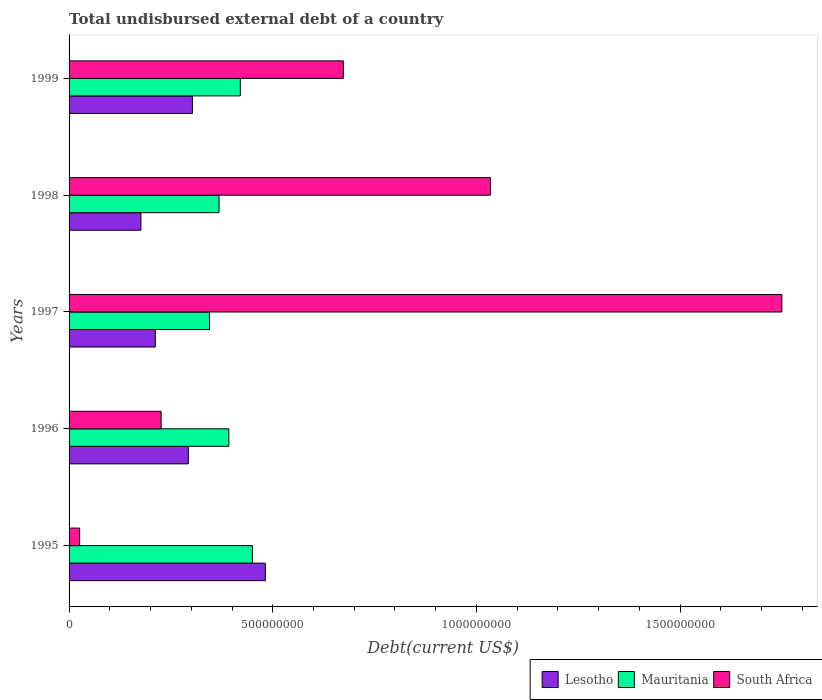How many groups of bars are there?
Your answer should be compact. 5. How many bars are there on the 3rd tick from the bottom?
Your answer should be compact. 3. In how many cases, is the number of bars for a given year not equal to the number of legend labels?
Keep it short and to the point. 0. What is the total undisbursed external debt in Lesotho in 1996?
Keep it short and to the point. 2.93e+08. Across all years, what is the maximum total undisbursed external debt in South Africa?
Give a very brief answer. 1.75e+09. Across all years, what is the minimum total undisbursed external debt in Mauritania?
Make the answer very short. 3.45e+08. What is the total total undisbursed external debt in Lesotho in the graph?
Offer a very short reply. 1.47e+09. What is the difference between the total undisbursed external debt in Lesotho in 1995 and that in 1997?
Your response must be concise. 2.70e+08. What is the difference between the total undisbursed external debt in Mauritania in 1996 and the total undisbursed external debt in Lesotho in 1997?
Keep it short and to the point. 1.81e+08. What is the average total undisbursed external debt in Mauritania per year?
Offer a very short reply. 3.95e+08. In the year 1995, what is the difference between the total undisbursed external debt in South Africa and total undisbursed external debt in Lesotho?
Provide a succinct answer. -4.56e+08. In how many years, is the total undisbursed external debt in Lesotho greater than 800000000 US$?
Provide a short and direct response. 0. What is the ratio of the total undisbursed external debt in South Africa in 1996 to that in 1997?
Your response must be concise. 0.13. What is the difference between the highest and the second highest total undisbursed external debt in Lesotho?
Offer a very short reply. 1.79e+08. What is the difference between the highest and the lowest total undisbursed external debt in Mauritania?
Your answer should be compact. 1.05e+08. In how many years, is the total undisbursed external debt in South Africa greater than the average total undisbursed external debt in South Africa taken over all years?
Your answer should be compact. 2. What does the 3rd bar from the top in 1999 represents?
Ensure brevity in your answer.  Lesotho. What does the 2nd bar from the bottom in 1995 represents?
Your answer should be compact. Mauritania. Is it the case that in every year, the sum of the total undisbursed external debt in Mauritania and total undisbursed external debt in Lesotho is greater than the total undisbursed external debt in South Africa?
Give a very brief answer. No. How many bars are there?
Keep it short and to the point. 15. Are the values on the major ticks of X-axis written in scientific E-notation?
Give a very brief answer. No. Where does the legend appear in the graph?
Your answer should be compact. Bottom right. How many legend labels are there?
Offer a very short reply. 3. How are the legend labels stacked?
Keep it short and to the point. Horizontal. What is the title of the graph?
Provide a short and direct response. Total undisbursed external debt of a country. What is the label or title of the X-axis?
Make the answer very short. Debt(current US$). What is the Debt(current US$) in Lesotho in 1995?
Ensure brevity in your answer.  4.82e+08. What is the Debt(current US$) in Mauritania in 1995?
Ensure brevity in your answer.  4.50e+08. What is the Debt(current US$) of South Africa in 1995?
Give a very brief answer. 2.59e+07. What is the Debt(current US$) in Lesotho in 1996?
Ensure brevity in your answer.  2.93e+08. What is the Debt(current US$) of Mauritania in 1996?
Your response must be concise. 3.92e+08. What is the Debt(current US$) of South Africa in 1996?
Provide a short and direct response. 2.26e+08. What is the Debt(current US$) of Lesotho in 1997?
Provide a succinct answer. 2.12e+08. What is the Debt(current US$) of Mauritania in 1997?
Your answer should be compact. 3.45e+08. What is the Debt(current US$) of South Africa in 1997?
Keep it short and to the point. 1.75e+09. What is the Debt(current US$) in Lesotho in 1998?
Offer a terse response. 1.76e+08. What is the Debt(current US$) in Mauritania in 1998?
Give a very brief answer. 3.68e+08. What is the Debt(current US$) of South Africa in 1998?
Ensure brevity in your answer.  1.03e+09. What is the Debt(current US$) in Lesotho in 1999?
Give a very brief answer. 3.03e+08. What is the Debt(current US$) in Mauritania in 1999?
Offer a terse response. 4.20e+08. What is the Debt(current US$) in South Africa in 1999?
Make the answer very short. 6.73e+08. Across all years, what is the maximum Debt(current US$) of Lesotho?
Make the answer very short. 4.82e+08. Across all years, what is the maximum Debt(current US$) of Mauritania?
Provide a succinct answer. 4.50e+08. Across all years, what is the maximum Debt(current US$) of South Africa?
Your answer should be compact. 1.75e+09. Across all years, what is the minimum Debt(current US$) of Lesotho?
Offer a very short reply. 1.76e+08. Across all years, what is the minimum Debt(current US$) in Mauritania?
Provide a short and direct response. 3.45e+08. Across all years, what is the minimum Debt(current US$) of South Africa?
Your answer should be very brief. 2.59e+07. What is the total Debt(current US$) of Lesotho in the graph?
Your answer should be compact. 1.47e+09. What is the total Debt(current US$) of Mauritania in the graph?
Your answer should be very brief. 1.98e+09. What is the total Debt(current US$) in South Africa in the graph?
Give a very brief answer. 3.71e+09. What is the difference between the Debt(current US$) of Lesotho in 1995 and that in 1996?
Offer a terse response. 1.89e+08. What is the difference between the Debt(current US$) in Mauritania in 1995 and that in 1996?
Provide a succinct answer. 5.79e+07. What is the difference between the Debt(current US$) of South Africa in 1995 and that in 1996?
Your response must be concise. -2.00e+08. What is the difference between the Debt(current US$) in Lesotho in 1995 and that in 1997?
Make the answer very short. 2.70e+08. What is the difference between the Debt(current US$) of Mauritania in 1995 and that in 1997?
Keep it short and to the point. 1.05e+08. What is the difference between the Debt(current US$) of South Africa in 1995 and that in 1997?
Your answer should be compact. -1.72e+09. What is the difference between the Debt(current US$) in Lesotho in 1995 and that in 1998?
Your answer should be compact. 3.06e+08. What is the difference between the Debt(current US$) in Mauritania in 1995 and that in 1998?
Offer a very short reply. 8.19e+07. What is the difference between the Debt(current US$) in South Africa in 1995 and that in 1998?
Keep it short and to the point. -1.01e+09. What is the difference between the Debt(current US$) in Lesotho in 1995 and that in 1999?
Ensure brevity in your answer.  1.79e+08. What is the difference between the Debt(current US$) of Mauritania in 1995 and that in 1999?
Provide a succinct answer. 2.96e+07. What is the difference between the Debt(current US$) of South Africa in 1995 and that in 1999?
Offer a terse response. -6.47e+08. What is the difference between the Debt(current US$) in Lesotho in 1996 and that in 1997?
Offer a very short reply. 8.11e+07. What is the difference between the Debt(current US$) in Mauritania in 1996 and that in 1997?
Ensure brevity in your answer.  4.75e+07. What is the difference between the Debt(current US$) of South Africa in 1996 and that in 1997?
Offer a very short reply. -1.52e+09. What is the difference between the Debt(current US$) of Lesotho in 1996 and that in 1998?
Ensure brevity in your answer.  1.16e+08. What is the difference between the Debt(current US$) in Mauritania in 1996 and that in 1998?
Ensure brevity in your answer.  2.40e+07. What is the difference between the Debt(current US$) of South Africa in 1996 and that in 1998?
Offer a very short reply. -8.08e+08. What is the difference between the Debt(current US$) in Lesotho in 1996 and that in 1999?
Offer a terse response. -1.01e+07. What is the difference between the Debt(current US$) in Mauritania in 1996 and that in 1999?
Your answer should be very brief. -2.82e+07. What is the difference between the Debt(current US$) in South Africa in 1996 and that in 1999?
Provide a succinct answer. -4.47e+08. What is the difference between the Debt(current US$) of Lesotho in 1997 and that in 1998?
Provide a short and direct response. 3.53e+07. What is the difference between the Debt(current US$) in Mauritania in 1997 and that in 1998?
Give a very brief answer. -2.35e+07. What is the difference between the Debt(current US$) in South Africa in 1997 and that in 1998?
Offer a terse response. 7.16e+08. What is the difference between the Debt(current US$) in Lesotho in 1997 and that in 1999?
Offer a terse response. -9.12e+07. What is the difference between the Debt(current US$) in Mauritania in 1997 and that in 1999?
Ensure brevity in your answer.  -7.57e+07. What is the difference between the Debt(current US$) of South Africa in 1997 and that in 1999?
Make the answer very short. 1.08e+09. What is the difference between the Debt(current US$) of Lesotho in 1998 and that in 1999?
Make the answer very short. -1.26e+08. What is the difference between the Debt(current US$) of Mauritania in 1998 and that in 1999?
Provide a short and direct response. -5.22e+07. What is the difference between the Debt(current US$) in South Africa in 1998 and that in 1999?
Your answer should be very brief. 3.61e+08. What is the difference between the Debt(current US$) of Lesotho in 1995 and the Debt(current US$) of Mauritania in 1996?
Make the answer very short. 8.97e+07. What is the difference between the Debt(current US$) of Lesotho in 1995 and the Debt(current US$) of South Africa in 1996?
Give a very brief answer. 2.56e+08. What is the difference between the Debt(current US$) of Mauritania in 1995 and the Debt(current US$) of South Africa in 1996?
Ensure brevity in your answer.  2.24e+08. What is the difference between the Debt(current US$) of Lesotho in 1995 and the Debt(current US$) of Mauritania in 1997?
Make the answer very short. 1.37e+08. What is the difference between the Debt(current US$) of Lesotho in 1995 and the Debt(current US$) of South Africa in 1997?
Your answer should be compact. -1.27e+09. What is the difference between the Debt(current US$) in Mauritania in 1995 and the Debt(current US$) in South Africa in 1997?
Your answer should be compact. -1.30e+09. What is the difference between the Debt(current US$) of Lesotho in 1995 and the Debt(current US$) of Mauritania in 1998?
Give a very brief answer. 1.14e+08. What is the difference between the Debt(current US$) of Lesotho in 1995 and the Debt(current US$) of South Africa in 1998?
Provide a succinct answer. -5.52e+08. What is the difference between the Debt(current US$) in Mauritania in 1995 and the Debt(current US$) in South Africa in 1998?
Offer a terse response. -5.84e+08. What is the difference between the Debt(current US$) in Lesotho in 1995 and the Debt(current US$) in Mauritania in 1999?
Your answer should be very brief. 6.15e+07. What is the difference between the Debt(current US$) of Lesotho in 1995 and the Debt(current US$) of South Africa in 1999?
Provide a succinct answer. -1.91e+08. What is the difference between the Debt(current US$) of Mauritania in 1995 and the Debt(current US$) of South Africa in 1999?
Your answer should be very brief. -2.23e+08. What is the difference between the Debt(current US$) in Lesotho in 1996 and the Debt(current US$) in Mauritania in 1997?
Ensure brevity in your answer.  -5.20e+07. What is the difference between the Debt(current US$) of Lesotho in 1996 and the Debt(current US$) of South Africa in 1997?
Your answer should be compact. -1.46e+09. What is the difference between the Debt(current US$) of Mauritania in 1996 and the Debt(current US$) of South Africa in 1997?
Offer a very short reply. -1.36e+09. What is the difference between the Debt(current US$) of Lesotho in 1996 and the Debt(current US$) of Mauritania in 1998?
Provide a short and direct response. -7.54e+07. What is the difference between the Debt(current US$) of Lesotho in 1996 and the Debt(current US$) of South Africa in 1998?
Ensure brevity in your answer.  -7.42e+08. What is the difference between the Debt(current US$) of Mauritania in 1996 and the Debt(current US$) of South Africa in 1998?
Provide a short and direct response. -6.42e+08. What is the difference between the Debt(current US$) in Lesotho in 1996 and the Debt(current US$) in Mauritania in 1999?
Your response must be concise. -1.28e+08. What is the difference between the Debt(current US$) in Lesotho in 1996 and the Debt(current US$) in South Africa in 1999?
Your answer should be very brief. -3.81e+08. What is the difference between the Debt(current US$) of Mauritania in 1996 and the Debt(current US$) of South Africa in 1999?
Offer a very short reply. -2.81e+08. What is the difference between the Debt(current US$) of Lesotho in 1997 and the Debt(current US$) of Mauritania in 1998?
Ensure brevity in your answer.  -1.57e+08. What is the difference between the Debt(current US$) of Lesotho in 1997 and the Debt(current US$) of South Africa in 1998?
Ensure brevity in your answer.  -8.23e+08. What is the difference between the Debt(current US$) in Mauritania in 1997 and the Debt(current US$) in South Africa in 1998?
Your answer should be very brief. -6.90e+08. What is the difference between the Debt(current US$) in Lesotho in 1997 and the Debt(current US$) in Mauritania in 1999?
Keep it short and to the point. -2.09e+08. What is the difference between the Debt(current US$) in Lesotho in 1997 and the Debt(current US$) in South Africa in 1999?
Your answer should be very brief. -4.62e+08. What is the difference between the Debt(current US$) in Mauritania in 1997 and the Debt(current US$) in South Africa in 1999?
Your answer should be compact. -3.29e+08. What is the difference between the Debt(current US$) of Lesotho in 1998 and the Debt(current US$) of Mauritania in 1999?
Provide a succinct answer. -2.44e+08. What is the difference between the Debt(current US$) in Lesotho in 1998 and the Debt(current US$) in South Africa in 1999?
Ensure brevity in your answer.  -4.97e+08. What is the difference between the Debt(current US$) of Mauritania in 1998 and the Debt(current US$) of South Africa in 1999?
Provide a succinct answer. -3.05e+08. What is the average Debt(current US$) of Lesotho per year?
Offer a terse response. 2.93e+08. What is the average Debt(current US$) of Mauritania per year?
Offer a very short reply. 3.95e+08. What is the average Debt(current US$) in South Africa per year?
Ensure brevity in your answer.  7.42e+08. In the year 1995, what is the difference between the Debt(current US$) of Lesotho and Debt(current US$) of Mauritania?
Your answer should be compact. 3.19e+07. In the year 1995, what is the difference between the Debt(current US$) in Lesotho and Debt(current US$) in South Africa?
Your response must be concise. 4.56e+08. In the year 1995, what is the difference between the Debt(current US$) in Mauritania and Debt(current US$) in South Africa?
Provide a short and direct response. 4.24e+08. In the year 1996, what is the difference between the Debt(current US$) in Lesotho and Debt(current US$) in Mauritania?
Keep it short and to the point. -9.94e+07. In the year 1996, what is the difference between the Debt(current US$) in Lesotho and Debt(current US$) in South Africa?
Offer a terse response. 6.68e+07. In the year 1996, what is the difference between the Debt(current US$) of Mauritania and Debt(current US$) of South Africa?
Keep it short and to the point. 1.66e+08. In the year 1997, what is the difference between the Debt(current US$) of Lesotho and Debt(current US$) of Mauritania?
Your answer should be compact. -1.33e+08. In the year 1997, what is the difference between the Debt(current US$) in Lesotho and Debt(current US$) in South Africa?
Give a very brief answer. -1.54e+09. In the year 1997, what is the difference between the Debt(current US$) in Mauritania and Debt(current US$) in South Africa?
Your response must be concise. -1.41e+09. In the year 1998, what is the difference between the Debt(current US$) in Lesotho and Debt(current US$) in Mauritania?
Provide a succinct answer. -1.92e+08. In the year 1998, what is the difference between the Debt(current US$) of Lesotho and Debt(current US$) of South Africa?
Offer a terse response. -8.58e+08. In the year 1998, what is the difference between the Debt(current US$) in Mauritania and Debt(current US$) in South Africa?
Provide a succinct answer. -6.66e+08. In the year 1999, what is the difference between the Debt(current US$) in Lesotho and Debt(current US$) in Mauritania?
Offer a terse response. -1.18e+08. In the year 1999, what is the difference between the Debt(current US$) in Lesotho and Debt(current US$) in South Africa?
Provide a short and direct response. -3.70e+08. In the year 1999, what is the difference between the Debt(current US$) of Mauritania and Debt(current US$) of South Africa?
Offer a very short reply. -2.53e+08. What is the ratio of the Debt(current US$) in Lesotho in 1995 to that in 1996?
Provide a succinct answer. 1.65. What is the ratio of the Debt(current US$) in Mauritania in 1995 to that in 1996?
Make the answer very short. 1.15. What is the ratio of the Debt(current US$) of South Africa in 1995 to that in 1996?
Offer a terse response. 0.11. What is the ratio of the Debt(current US$) in Lesotho in 1995 to that in 1997?
Your response must be concise. 2.28. What is the ratio of the Debt(current US$) in Mauritania in 1995 to that in 1997?
Provide a succinct answer. 1.31. What is the ratio of the Debt(current US$) of South Africa in 1995 to that in 1997?
Give a very brief answer. 0.01. What is the ratio of the Debt(current US$) of Lesotho in 1995 to that in 1998?
Offer a very short reply. 2.73. What is the ratio of the Debt(current US$) of Mauritania in 1995 to that in 1998?
Provide a succinct answer. 1.22. What is the ratio of the Debt(current US$) in South Africa in 1995 to that in 1998?
Offer a very short reply. 0.03. What is the ratio of the Debt(current US$) of Lesotho in 1995 to that in 1999?
Keep it short and to the point. 1.59. What is the ratio of the Debt(current US$) in Mauritania in 1995 to that in 1999?
Your answer should be compact. 1.07. What is the ratio of the Debt(current US$) in South Africa in 1995 to that in 1999?
Provide a short and direct response. 0.04. What is the ratio of the Debt(current US$) in Lesotho in 1996 to that in 1997?
Provide a short and direct response. 1.38. What is the ratio of the Debt(current US$) of Mauritania in 1996 to that in 1997?
Your response must be concise. 1.14. What is the ratio of the Debt(current US$) of South Africa in 1996 to that in 1997?
Provide a short and direct response. 0.13. What is the ratio of the Debt(current US$) of Lesotho in 1996 to that in 1998?
Your answer should be compact. 1.66. What is the ratio of the Debt(current US$) of Mauritania in 1996 to that in 1998?
Give a very brief answer. 1.07. What is the ratio of the Debt(current US$) in South Africa in 1996 to that in 1998?
Your answer should be compact. 0.22. What is the ratio of the Debt(current US$) in Lesotho in 1996 to that in 1999?
Ensure brevity in your answer.  0.97. What is the ratio of the Debt(current US$) in Mauritania in 1996 to that in 1999?
Provide a short and direct response. 0.93. What is the ratio of the Debt(current US$) of South Africa in 1996 to that in 1999?
Offer a terse response. 0.34. What is the ratio of the Debt(current US$) of Lesotho in 1997 to that in 1998?
Ensure brevity in your answer.  1.2. What is the ratio of the Debt(current US$) of Mauritania in 1997 to that in 1998?
Make the answer very short. 0.94. What is the ratio of the Debt(current US$) of South Africa in 1997 to that in 1998?
Give a very brief answer. 1.69. What is the ratio of the Debt(current US$) in Lesotho in 1997 to that in 1999?
Your answer should be very brief. 0.7. What is the ratio of the Debt(current US$) of Mauritania in 1997 to that in 1999?
Ensure brevity in your answer.  0.82. What is the ratio of the Debt(current US$) in South Africa in 1997 to that in 1999?
Offer a terse response. 2.6. What is the ratio of the Debt(current US$) of Lesotho in 1998 to that in 1999?
Your answer should be compact. 0.58. What is the ratio of the Debt(current US$) of Mauritania in 1998 to that in 1999?
Provide a short and direct response. 0.88. What is the ratio of the Debt(current US$) of South Africa in 1998 to that in 1999?
Your answer should be very brief. 1.54. What is the difference between the highest and the second highest Debt(current US$) in Lesotho?
Your answer should be compact. 1.79e+08. What is the difference between the highest and the second highest Debt(current US$) of Mauritania?
Your answer should be compact. 2.96e+07. What is the difference between the highest and the second highest Debt(current US$) of South Africa?
Offer a terse response. 7.16e+08. What is the difference between the highest and the lowest Debt(current US$) of Lesotho?
Give a very brief answer. 3.06e+08. What is the difference between the highest and the lowest Debt(current US$) in Mauritania?
Your answer should be very brief. 1.05e+08. What is the difference between the highest and the lowest Debt(current US$) in South Africa?
Give a very brief answer. 1.72e+09. 